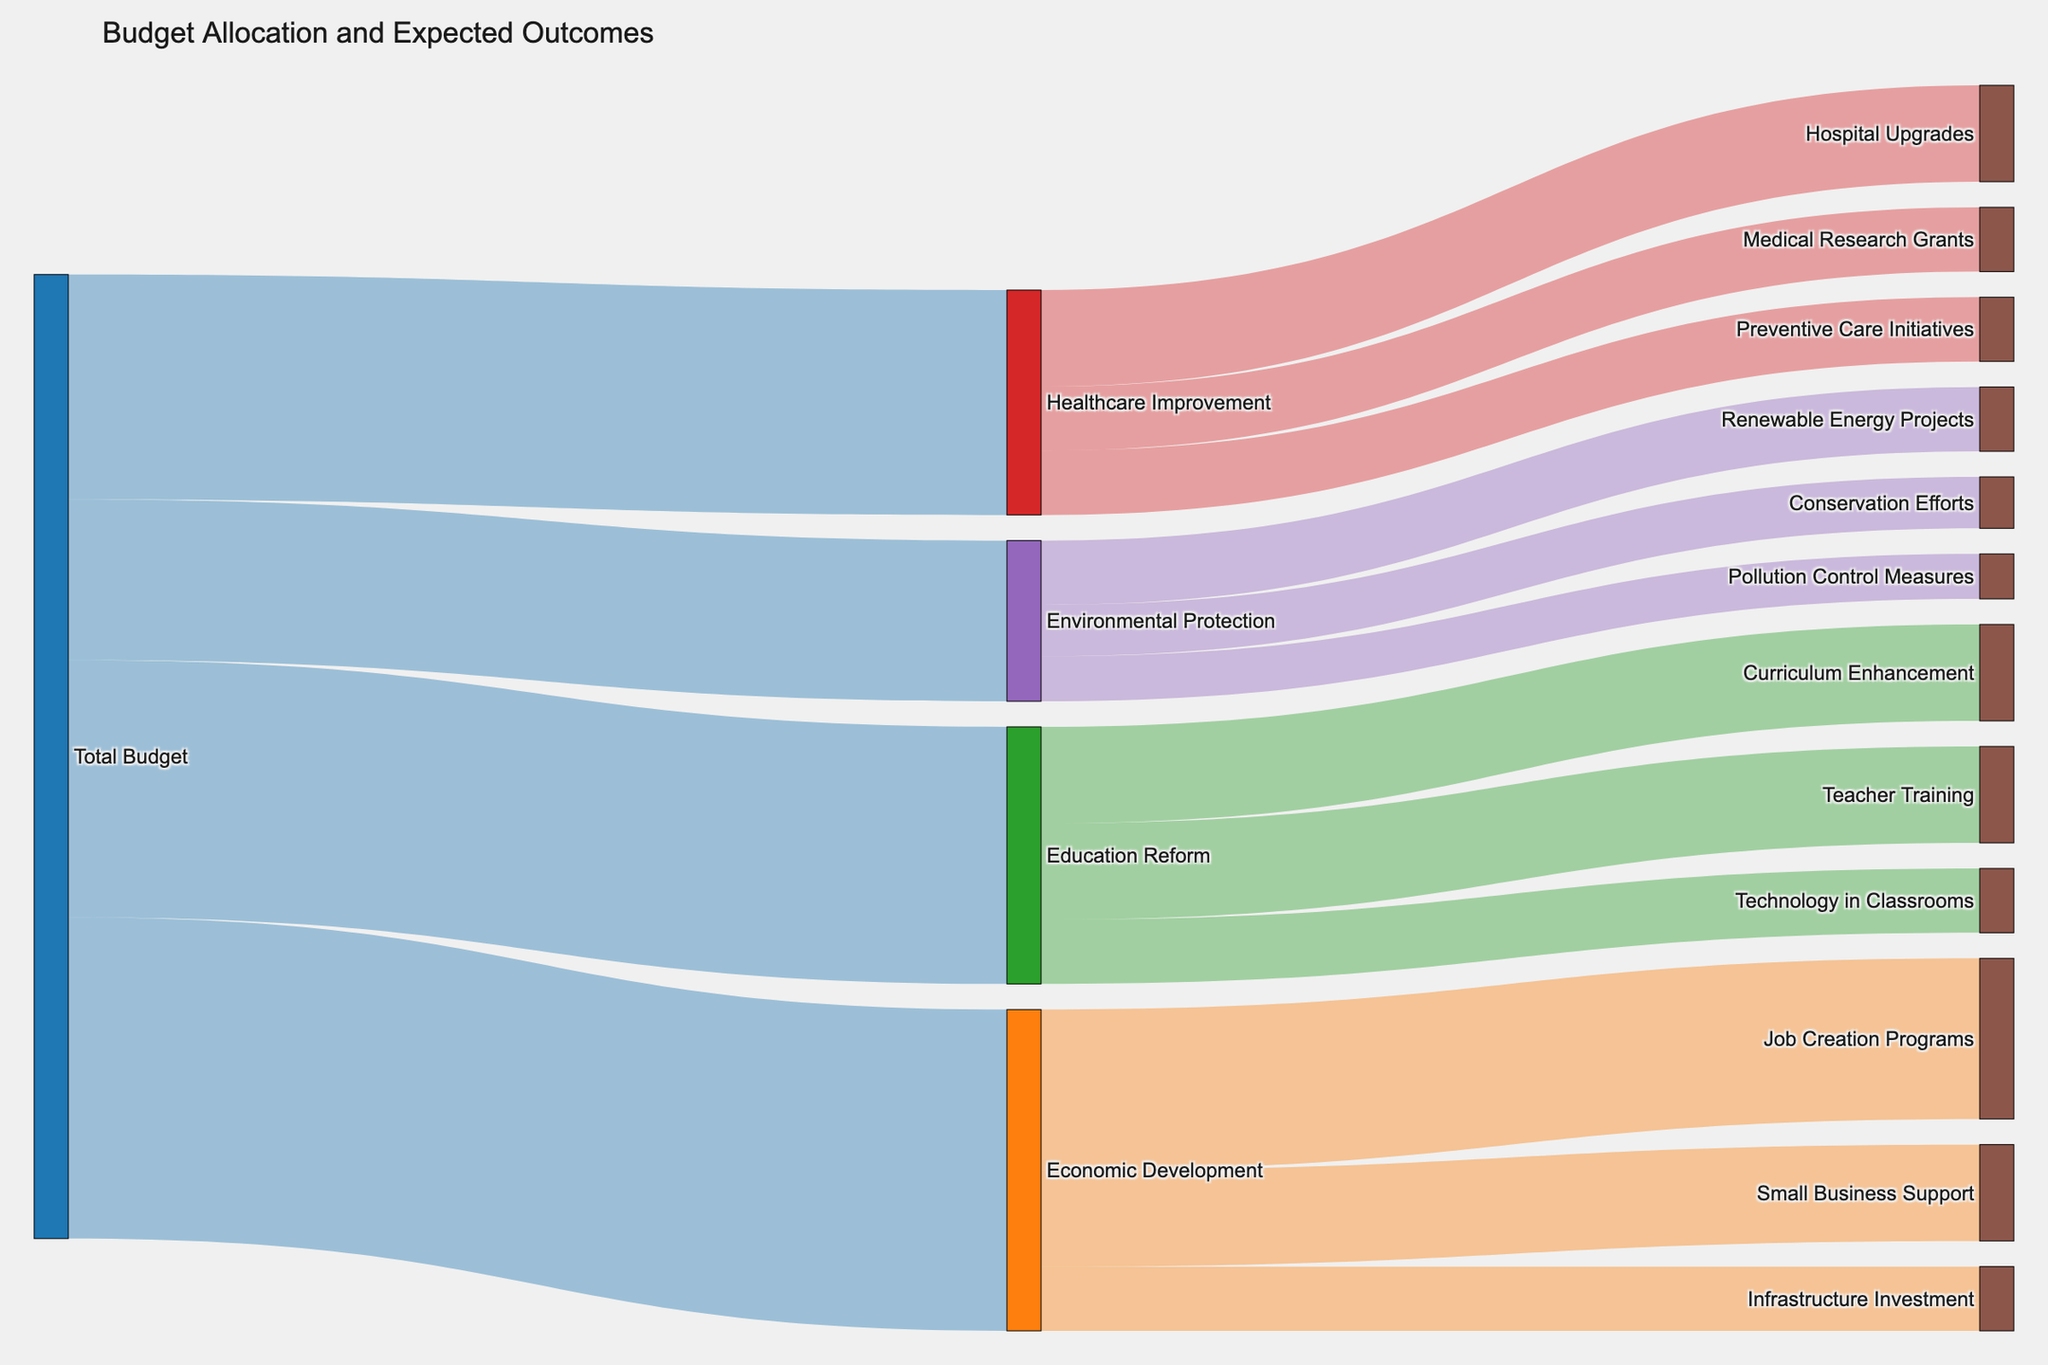What are the four main policy initiatives listed in the diagram? The four main policy initiatives are directly connected to the "Total Budget" node and are "Economic Development," "Education Reform," "Healthcare Improvement," and "Environmental Protection."
Answer: Economic Development, Education Reform, Healthcare Improvement, Environmental Protection How much budget is allocated to Environmental Protection? The value connected between "Total Budget" and "Environmental Protection" indicates the budget allocation, which is labeled as 2,500,000.
Answer: 2,500,000 Which initiative receives the highest budget allocation? By comparing the values connected from "Total Budget" to the policy initiatives, "Economic Development" has the highest allocation at 5,000,000.
Answer: Economic Development What is the combined budget for Teacher Training and Curriculum Enhancement under Education Reform? The values for "Teacher Training" and "Curriculum Enhancement" are 1,500,000 and 1,500,000 respectively. Adding them gives 3,000,000.
Answer: 3,000,000 Which specific outcome under Environmental Protection has the smallest budget allocation? Under "Environmental Protection," compare the values for "Renewable Energy Projects" (1,000,000), "Conservation Efforts" (800,000), and "Pollution Control Measures" (700,000). "Pollution Control Measures" has the smallest allocation.
Answer: Pollution Control Measures What is the total budget allocation across all policy initiatives? Sum the values connected from "Total Budget" to each initiative: 5,000,000 + 4,000,000 + 3,500,000 + 2,500,000 which totals 15,000,000.
Answer: 15,000,000 How does the budget for Hospital Upgrades compare to that for Renewable Energy Projects? "Hospital Upgrades" under "Healthcare Improvement" has a budget of 1,500,000, whereas "Renewable Energy Projects" under "Environmental Protection" has a budget of 1,000,000. Therefore, Hospital Upgrades receive more.
Answer: Hospital Upgrades receive more What is the total budget allocated for Economic Development sub-initiatives? Sum the values for "Job Creation Programs" (2,500,000), "Small Business Support" (1,500,000), and "Infrastructure Investment" (1,000,000). The total is 5,000,000.
Answer: 5,000,000 How much more budget is allocated to Healthcare Improvement compared to Environmental Protection? The values are 3,500,000 for Healthcare Improvement and 2,500,000 for Environmental Protection. Subtracting these gives 1,000,000 more for Healthcare Improvement.
Answer: 1,000,000 Which sub-initiative under Education Reform has the highest allocation? Compare "Teacher Training" (1,500,000), "Technology in Classrooms" (1,000,000), and "Curriculum Enhancement" (1,500,000). "Teacher Training" and "Curriculum Enhancement" both receive the highest allocation.
Answer: Teacher Training, Curriculum Enhancement 